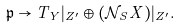Convert formula to latex. <formula><loc_0><loc_0><loc_500><loc_500>\mathfrak { p } \rightarrow T _ { Y } | _ { Z ^ { \prime } } \oplus ( \mathcal { N } _ { S } X ) | _ { Z ^ { \prime } } .</formula> 